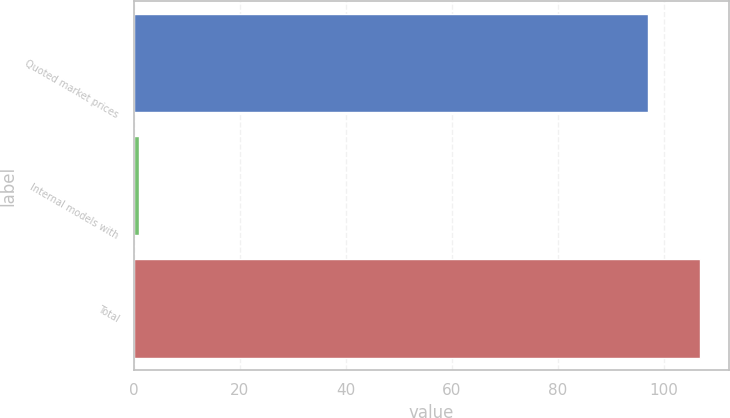<chart> <loc_0><loc_0><loc_500><loc_500><bar_chart><fcel>Quoted market prices<fcel>Internal models with<fcel>Total<nl><fcel>97<fcel>1<fcel>106.9<nl></chart> 